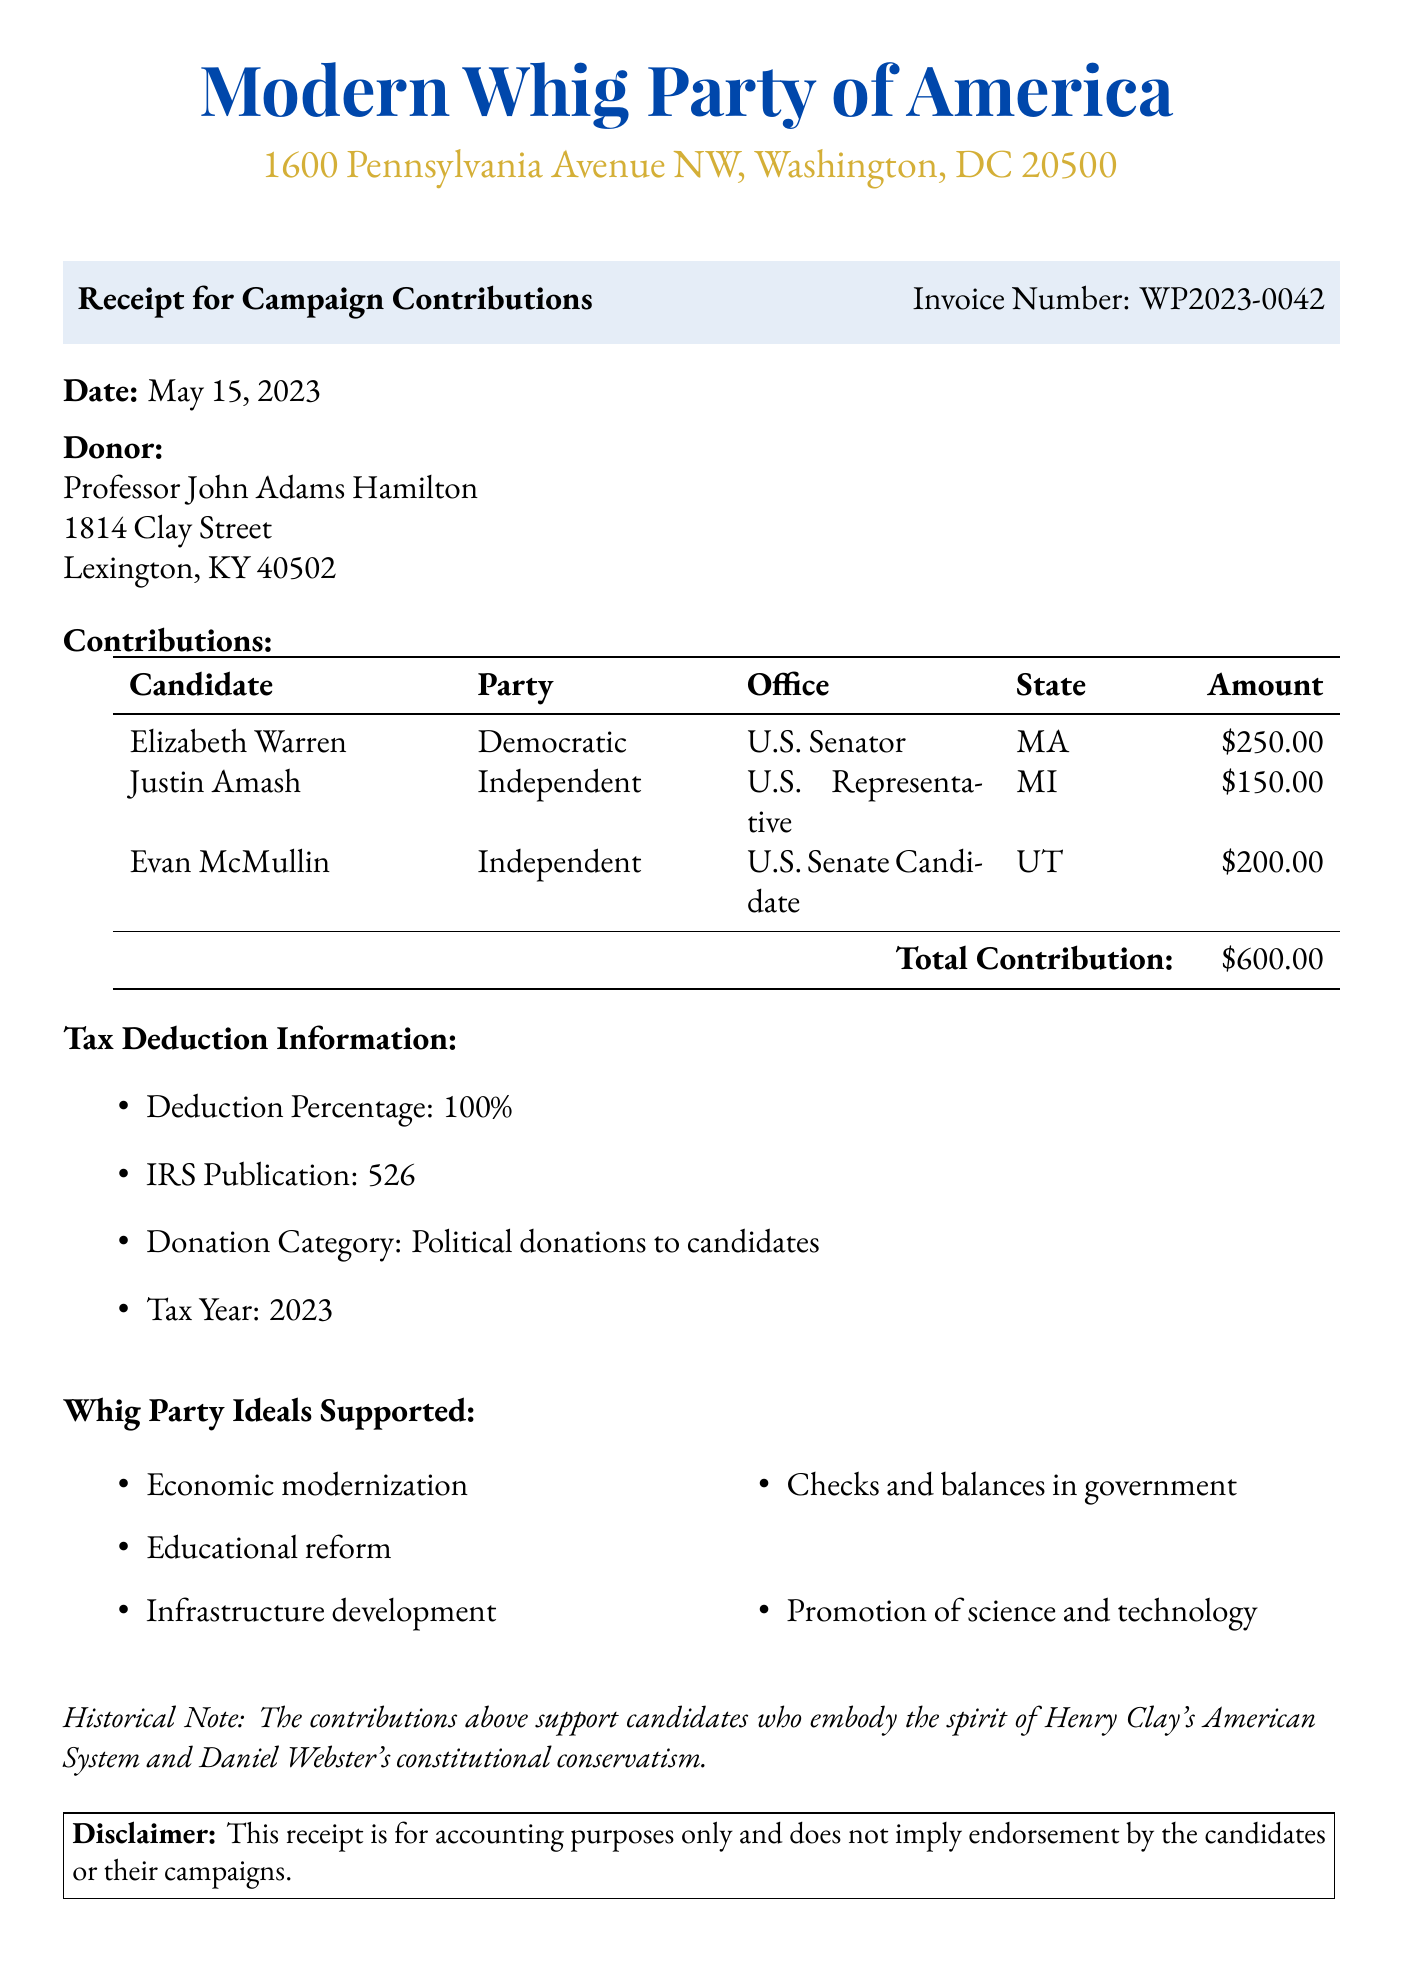What is the invoice number? The invoice number is listed at the top of the document for reference.
Answer: WP2023-0042 Who is the donor? The donor's name is specified under the donor section of the document.
Answer: Professor John Adams Hamilton What is the total contribution amount? The total contribution amount is calculated from the contributions made and is shown towards the end of the contributions table.
Answer: $600.00 What percentage is the tax deduction? The tax deduction information specifies the percentage that can be deducted.
Answer: 100% Which candidate received the highest contribution amount? To determine the candidate with the highest contribution, we review the amounts listed next to each candidate.
Answer: Elizabeth Warren How many candidates received contributions? To find this, we can count the distinct candidates listed in the contributions section.
Answer: 3 What is the IRS publication number related to tax deductions? The IRS publication number is mentioned under tax deduction information in the document.
Answer: 526 What historical figure's ideals does this document reference? The historical note at the end references key figures related to Whig party ideals.
Answer: Henry Clay What is the address of the recipient organization? The document contains the address of the recipient organization, which is located in Washington, DC.
Answer: 1600 Pennsylvania Avenue NW, Washington, DC 20500 